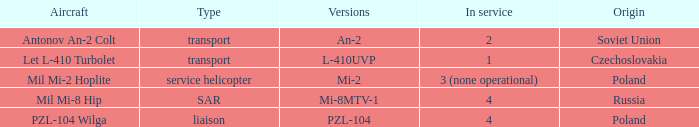Can you give me this table as a dict? {'header': ['Aircraft', 'Type', 'Versions', 'In service', 'Origin'], 'rows': [['Antonov An-2 Colt', 'transport', 'An-2', '2', 'Soviet Union'], ['Let L-410 Turbolet', 'transport', 'L-410UVP', '1', 'Czechoslovakia'], ['Mil Mi-2 Hoplite', 'service helicopter', 'Mi-2', '3 (none operational)', 'Poland'], ['Mil Mi-8 Hip', 'SAR', 'Mi-8MTV-1', '4', 'Russia'], ['PZL-104 Wilga', 'liaison', 'PZL-104', '4', 'Poland']]} Tell me the service for versions l-410uvp 1.0. 